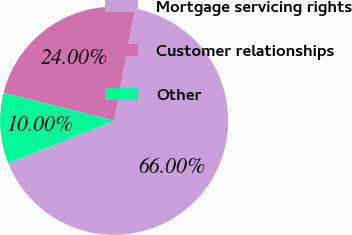<chart> <loc_0><loc_0><loc_500><loc_500><pie_chart><fcel>Mortgage servicing rights<fcel>Customer relationships<fcel>Other<nl><fcel>66.0%<fcel>24.0%<fcel>10.0%<nl></chart> 